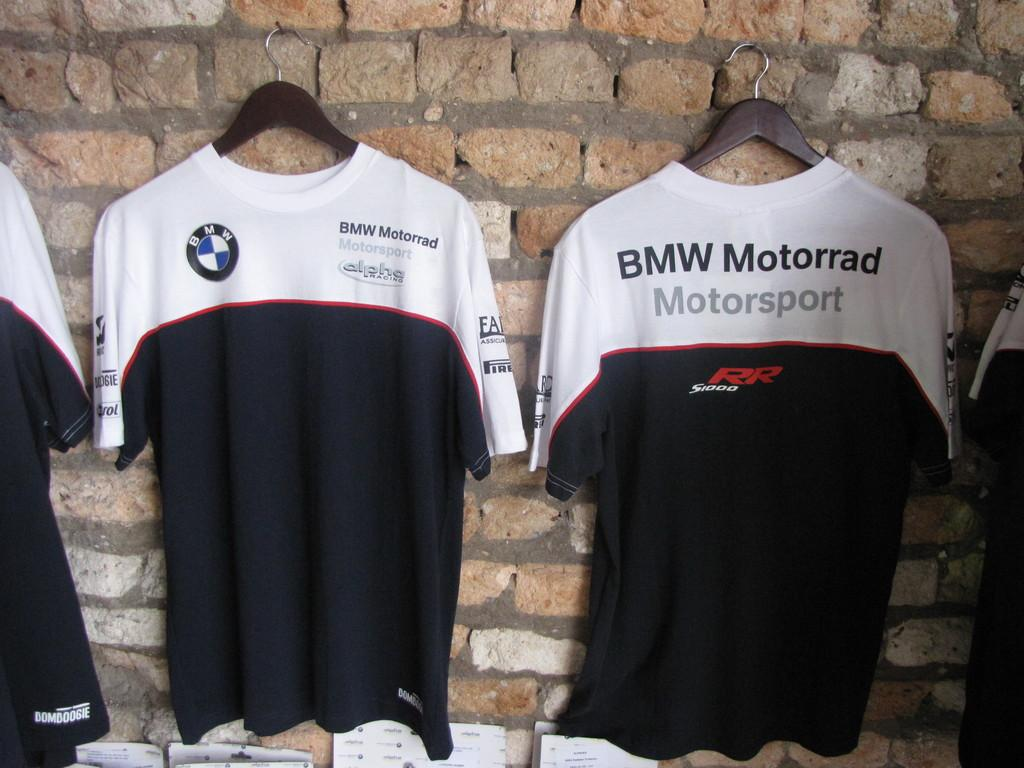Provide a one-sentence caption for the provided image. BMW Mororrad Motorsport tops hanging on a wall together. 